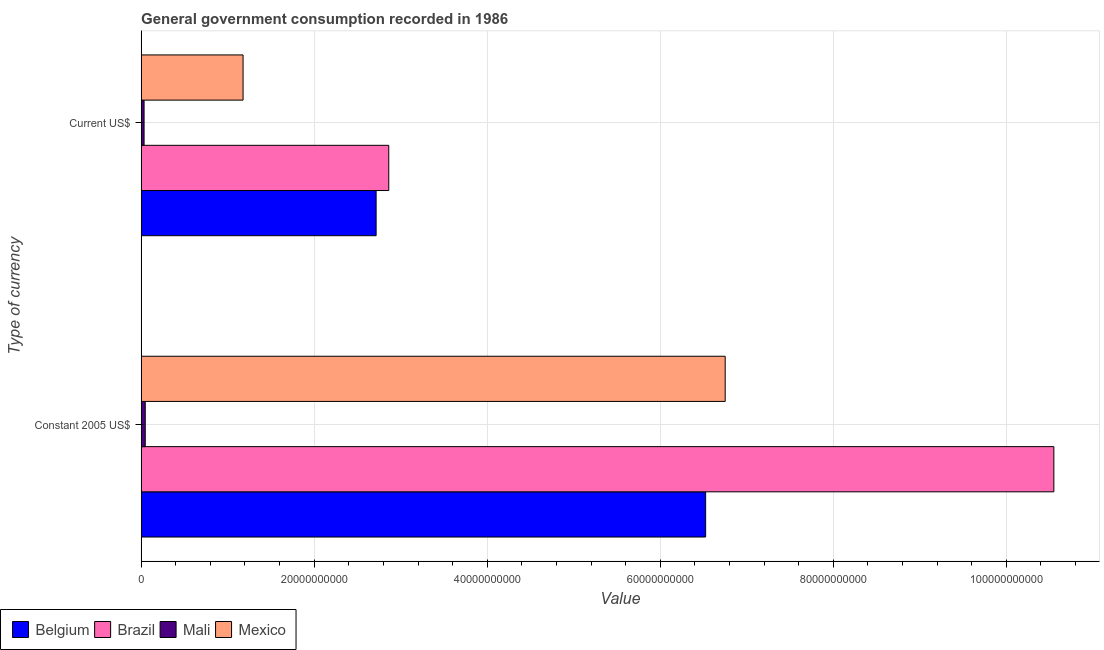How many different coloured bars are there?
Provide a succinct answer. 4. Are the number of bars on each tick of the Y-axis equal?
Your answer should be compact. Yes. How many bars are there on the 2nd tick from the top?
Offer a terse response. 4. What is the label of the 1st group of bars from the top?
Ensure brevity in your answer.  Current US$. What is the value consumed in current us$ in Mexico?
Provide a short and direct response. 1.18e+1. Across all countries, what is the maximum value consumed in current us$?
Give a very brief answer. 2.86e+1. Across all countries, what is the minimum value consumed in current us$?
Provide a succinct answer. 3.39e+08. In which country was the value consumed in current us$ maximum?
Provide a short and direct response. Brazil. In which country was the value consumed in constant 2005 us$ minimum?
Make the answer very short. Mali. What is the total value consumed in current us$ in the graph?
Your response must be concise. 6.79e+1. What is the difference between the value consumed in current us$ in Belgium and that in Mali?
Give a very brief answer. 2.68e+1. What is the difference between the value consumed in current us$ in Brazil and the value consumed in constant 2005 us$ in Mexico?
Provide a succinct answer. -3.89e+1. What is the average value consumed in constant 2005 us$ per country?
Your answer should be compact. 5.97e+1. What is the difference between the value consumed in current us$ and value consumed in constant 2005 us$ in Mali?
Make the answer very short. -1.35e+08. In how many countries, is the value consumed in constant 2005 us$ greater than 44000000000 ?
Make the answer very short. 3. What is the ratio of the value consumed in current us$ in Brazil to that in Mali?
Make the answer very short. 84.38. In how many countries, is the value consumed in current us$ greater than the average value consumed in current us$ taken over all countries?
Keep it short and to the point. 2. What does the 2nd bar from the top in Constant 2005 US$ represents?
Provide a short and direct response. Mali. Are all the bars in the graph horizontal?
Make the answer very short. Yes. How many countries are there in the graph?
Your answer should be compact. 4. Are the values on the major ticks of X-axis written in scientific E-notation?
Provide a short and direct response. No. Does the graph contain grids?
Offer a very short reply. Yes. Where does the legend appear in the graph?
Offer a terse response. Bottom left. What is the title of the graph?
Your answer should be very brief. General government consumption recorded in 1986. Does "Tajikistan" appear as one of the legend labels in the graph?
Provide a succinct answer. No. What is the label or title of the X-axis?
Keep it short and to the point. Value. What is the label or title of the Y-axis?
Keep it short and to the point. Type of currency. What is the Value in Belgium in Constant 2005 US$?
Your answer should be very brief. 6.52e+1. What is the Value in Brazil in Constant 2005 US$?
Your response must be concise. 1.05e+11. What is the Value of Mali in Constant 2005 US$?
Offer a very short reply. 4.74e+08. What is the Value of Mexico in Constant 2005 US$?
Provide a short and direct response. 6.75e+1. What is the Value in Belgium in Current US$?
Give a very brief answer. 2.72e+1. What is the Value in Brazil in Current US$?
Your response must be concise. 2.86e+1. What is the Value of Mali in Current US$?
Keep it short and to the point. 3.39e+08. What is the Value in Mexico in Current US$?
Keep it short and to the point. 1.18e+1. Across all Type of currency, what is the maximum Value in Belgium?
Ensure brevity in your answer.  6.52e+1. Across all Type of currency, what is the maximum Value in Brazil?
Provide a short and direct response. 1.05e+11. Across all Type of currency, what is the maximum Value of Mali?
Your response must be concise. 4.74e+08. Across all Type of currency, what is the maximum Value in Mexico?
Provide a short and direct response. 6.75e+1. Across all Type of currency, what is the minimum Value in Belgium?
Offer a very short reply. 2.72e+1. Across all Type of currency, what is the minimum Value of Brazil?
Offer a terse response. 2.86e+1. Across all Type of currency, what is the minimum Value of Mali?
Provide a short and direct response. 3.39e+08. Across all Type of currency, what is the minimum Value in Mexico?
Give a very brief answer. 1.18e+1. What is the total Value of Belgium in the graph?
Your answer should be very brief. 9.24e+1. What is the total Value in Brazil in the graph?
Your answer should be very brief. 1.34e+11. What is the total Value of Mali in the graph?
Give a very brief answer. 8.13e+08. What is the total Value in Mexico in the graph?
Ensure brevity in your answer.  7.93e+1. What is the difference between the Value in Belgium in Constant 2005 US$ and that in Current US$?
Your answer should be very brief. 3.81e+1. What is the difference between the Value of Brazil in Constant 2005 US$ and that in Current US$?
Provide a succinct answer. 7.69e+1. What is the difference between the Value in Mali in Constant 2005 US$ and that in Current US$?
Offer a terse response. 1.35e+08. What is the difference between the Value in Mexico in Constant 2005 US$ and that in Current US$?
Offer a terse response. 5.57e+1. What is the difference between the Value in Belgium in Constant 2005 US$ and the Value in Brazil in Current US$?
Your answer should be very brief. 3.66e+1. What is the difference between the Value of Belgium in Constant 2005 US$ and the Value of Mali in Current US$?
Your response must be concise. 6.49e+1. What is the difference between the Value in Belgium in Constant 2005 US$ and the Value in Mexico in Current US$?
Offer a very short reply. 5.35e+1. What is the difference between the Value of Brazil in Constant 2005 US$ and the Value of Mali in Current US$?
Your response must be concise. 1.05e+11. What is the difference between the Value in Brazil in Constant 2005 US$ and the Value in Mexico in Current US$?
Your response must be concise. 9.37e+1. What is the difference between the Value in Mali in Constant 2005 US$ and the Value in Mexico in Current US$?
Your answer should be very brief. -1.13e+1. What is the average Value in Belgium per Type of currency?
Your response must be concise. 4.62e+1. What is the average Value of Brazil per Type of currency?
Provide a succinct answer. 6.71e+1. What is the average Value of Mali per Type of currency?
Make the answer very short. 4.07e+08. What is the average Value of Mexico per Type of currency?
Offer a terse response. 3.96e+1. What is the difference between the Value in Belgium and Value in Brazil in Constant 2005 US$?
Make the answer very short. -4.02e+1. What is the difference between the Value of Belgium and Value of Mali in Constant 2005 US$?
Make the answer very short. 6.48e+1. What is the difference between the Value of Belgium and Value of Mexico in Constant 2005 US$?
Keep it short and to the point. -2.26e+09. What is the difference between the Value in Brazil and Value in Mali in Constant 2005 US$?
Offer a very short reply. 1.05e+11. What is the difference between the Value of Brazil and Value of Mexico in Constant 2005 US$?
Your answer should be very brief. 3.80e+1. What is the difference between the Value in Mali and Value in Mexico in Constant 2005 US$?
Offer a terse response. -6.70e+1. What is the difference between the Value of Belgium and Value of Brazil in Current US$?
Provide a short and direct response. -1.46e+09. What is the difference between the Value in Belgium and Value in Mali in Current US$?
Offer a very short reply. 2.68e+1. What is the difference between the Value of Belgium and Value of Mexico in Current US$?
Provide a succinct answer. 1.54e+1. What is the difference between the Value in Brazil and Value in Mali in Current US$?
Provide a short and direct response. 2.83e+1. What is the difference between the Value of Brazil and Value of Mexico in Current US$?
Ensure brevity in your answer.  1.68e+1. What is the difference between the Value of Mali and Value of Mexico in Current US$?
Your answer should be compact. -1.14e+1. What is the ratio of the Value in Belgium in Constant 2005 US$ to that in Current US$?
Your response must be concise. 2.4. What is the ratio of the Value of Brazil in Constant 2005 US$ to that in Current US$?
Your answer should be very brief. 3.69. What is the ratio of the Value in Mali in Constant 2005 US$ to that in Current US$?
Make the answer very short. 1.4. What is the ratio of the Value in Mexico in Constant 2005 US$ to that in Current US$?
Your answer should be very brief. 5.73. What is the difference between the highest and the second highest Value of Belgium?
Give a very brief answer. 3.81e+1. What is the difference between the highest and the second highest Value in Brazil?
Offer a very short reply. 7.69e+1. What is the difference between the highest and the second highest Value in Mali?
Your response must be concise. 1.35e+08. What is the difference between the highest and the second highest Value in Mexico?
Keep it short and to the point. 5.57e+1. What is the difference between the highest and the lowest Value of Belgium?
Offer a very short reply. 3.81e+1. What is the difference between the highest and the lowest Value of Brazil?
Your response must be concise. 7.69e+1. What is the difference between the highest and the lowest Value of Mali?
Provide a short and direct response. 1.35e+08. What is the difference between the highest and the lowest Value of Mexico?
Give a very brief answer. 5.57e+1. 